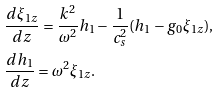<formula> <loc_0><loc_0><loc_500><loc_500>& \frac { d \xi _ { 1 z } } { d z } = \frac { k ^ { 2 } } { \omega ^ { 2 } } h _ { 1 } - \frac { 1 } { c _ { s } ^ { 2 } } ( h _ { 1 } - g _ { 0 } \xi _ { 1 z } ) , \\ & \frac { d h _ { 1 } } { d z } = \omega ^ { 2 } \xi _ { 1 z } .</formula> 